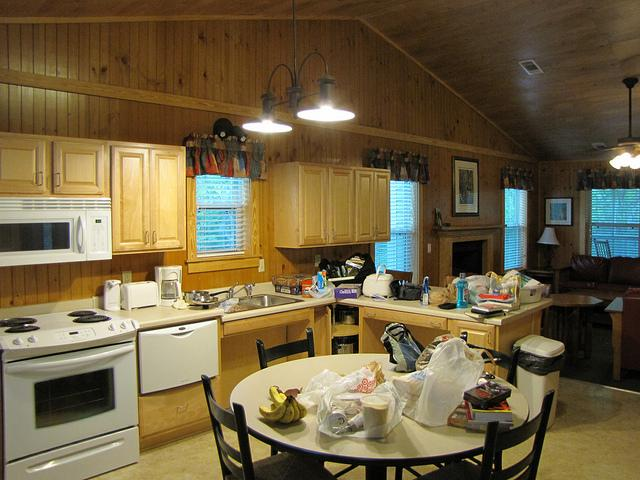What is on top of the dining table? groceries 